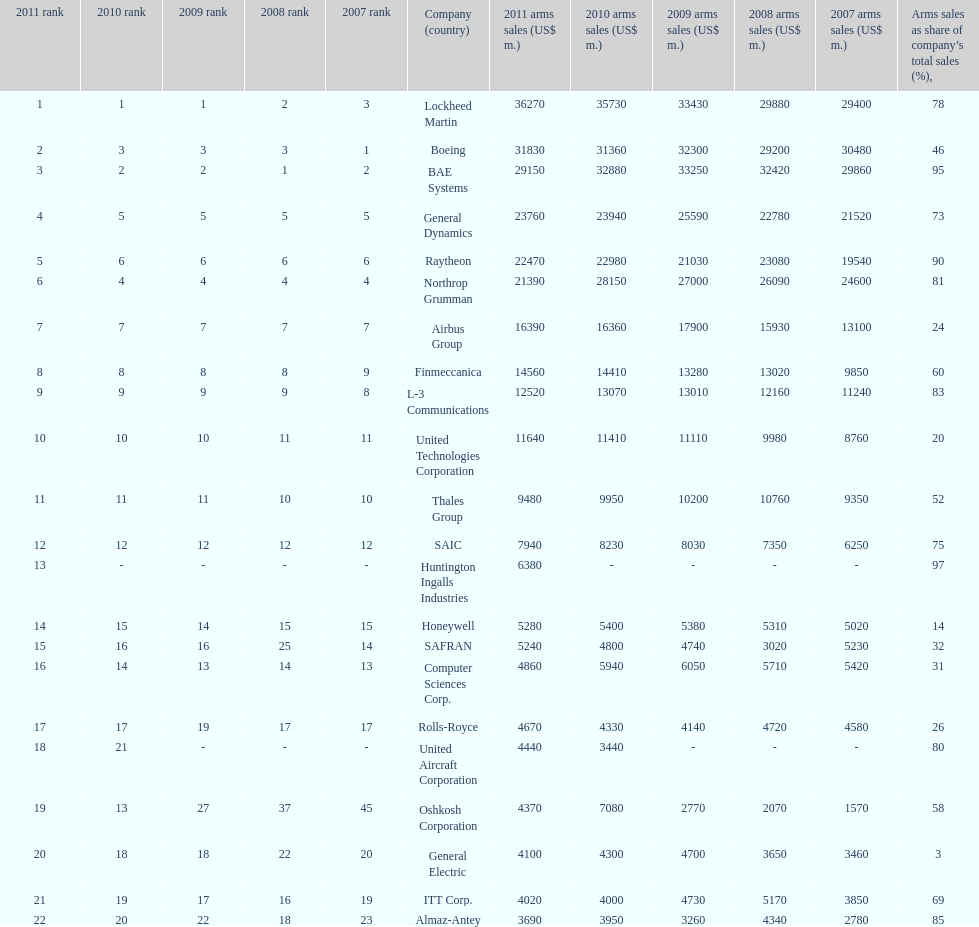What is the contrast in the number of items sold between boeing and general dynamics in 2007? 8960. 